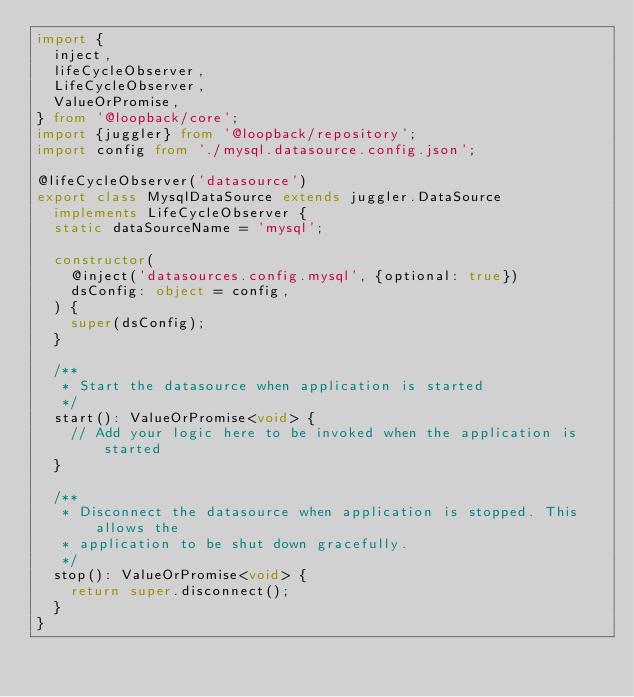Convert code to text. <code><loc_0><loc_0><loc_500><loc_500><_TypeScript_>import {
  inject,
  lifeCycleObserver,
  LifeCycleObserver,
  ValueOrPromise,
} from '@loopback/core';
import {juggler} from '@loopback/repository';
import config from './mysql.datasource.config.json';

@lifeCycleObserver('datasource')
export class MysqlDataSource extends juggler.DataSource
  implements LifeCycleObserver {
  static dataSourceName = 'mysql';

  constructor(
    @inject('datasources.config.mysql', {optional: true})
    dsConfig: object = config,
  ) {
    super(dsConfig);
  }

  /**
   * Start the datasource when application is started
   */
  start(): ValueOrPromise<void> {
    // Add your logic here to be invoked when the application is started
  }

  /**
   * Disconnect the datasource when application is stopped. This allows the
   * application to be shut down gracefully.
   */
  stop(): ValueOrPromise<void> {
    return super.disconnect();
  }
}
</code> 